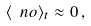Convert formula to latex. <formula><loc_0><loc_0><loc_500><loc_500>\langle \ n o \rangle _ { t } \approx 0 \, ,</formula> 